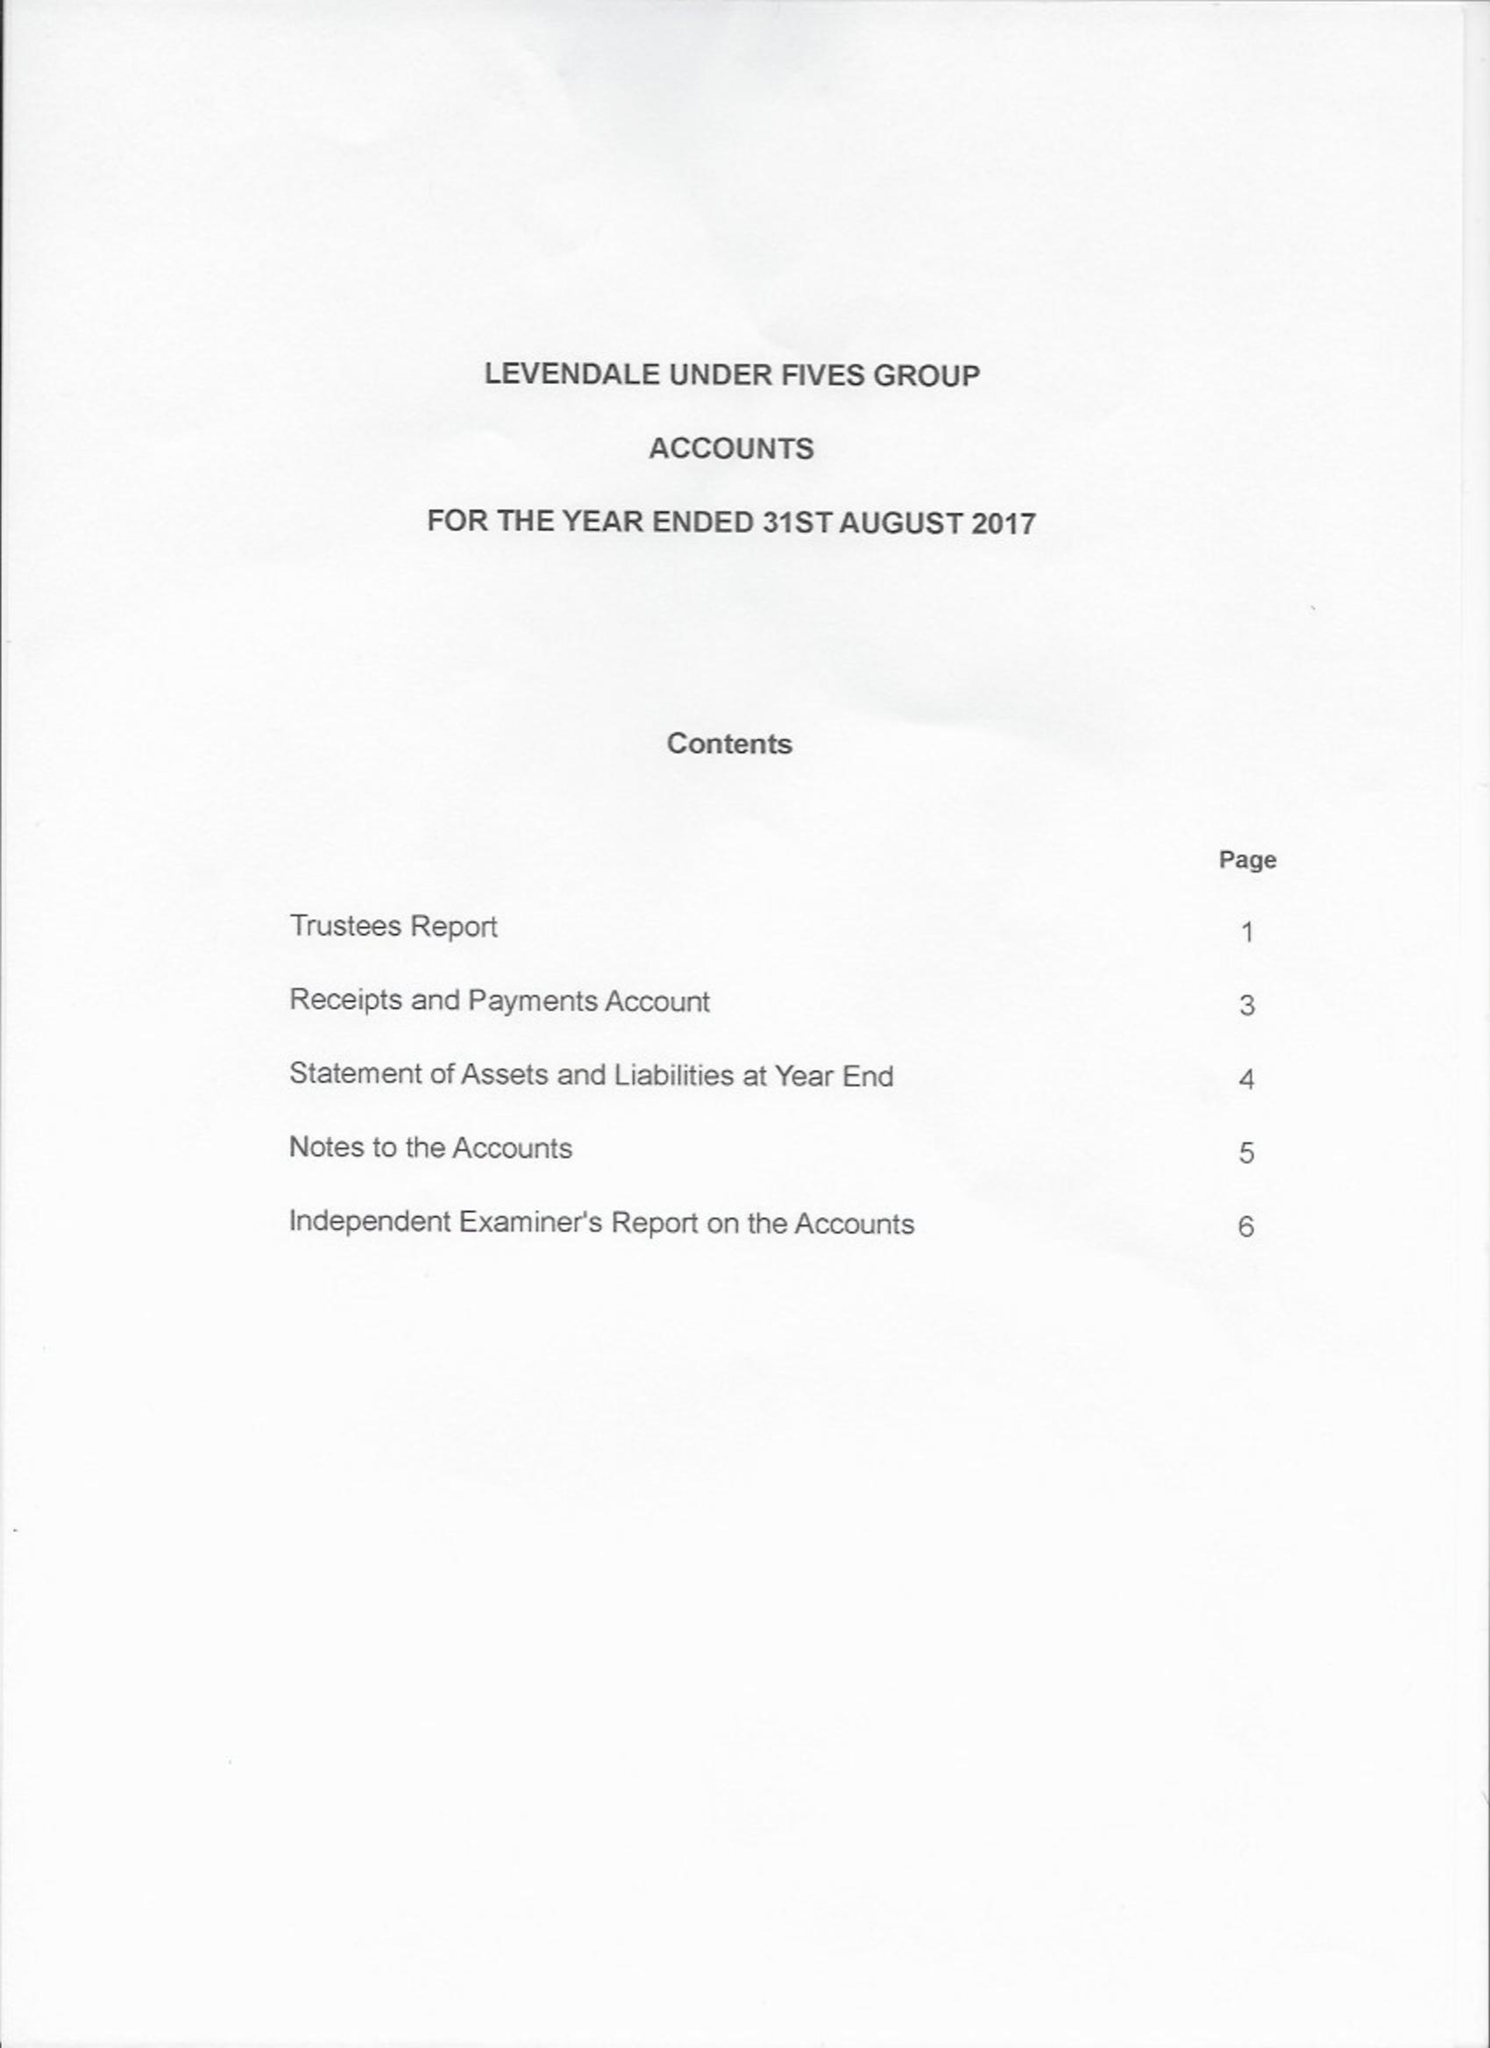What is the value for the address__street_line?
Answer the question using a single word or phrase. MOUNT LEVEN ROAD 